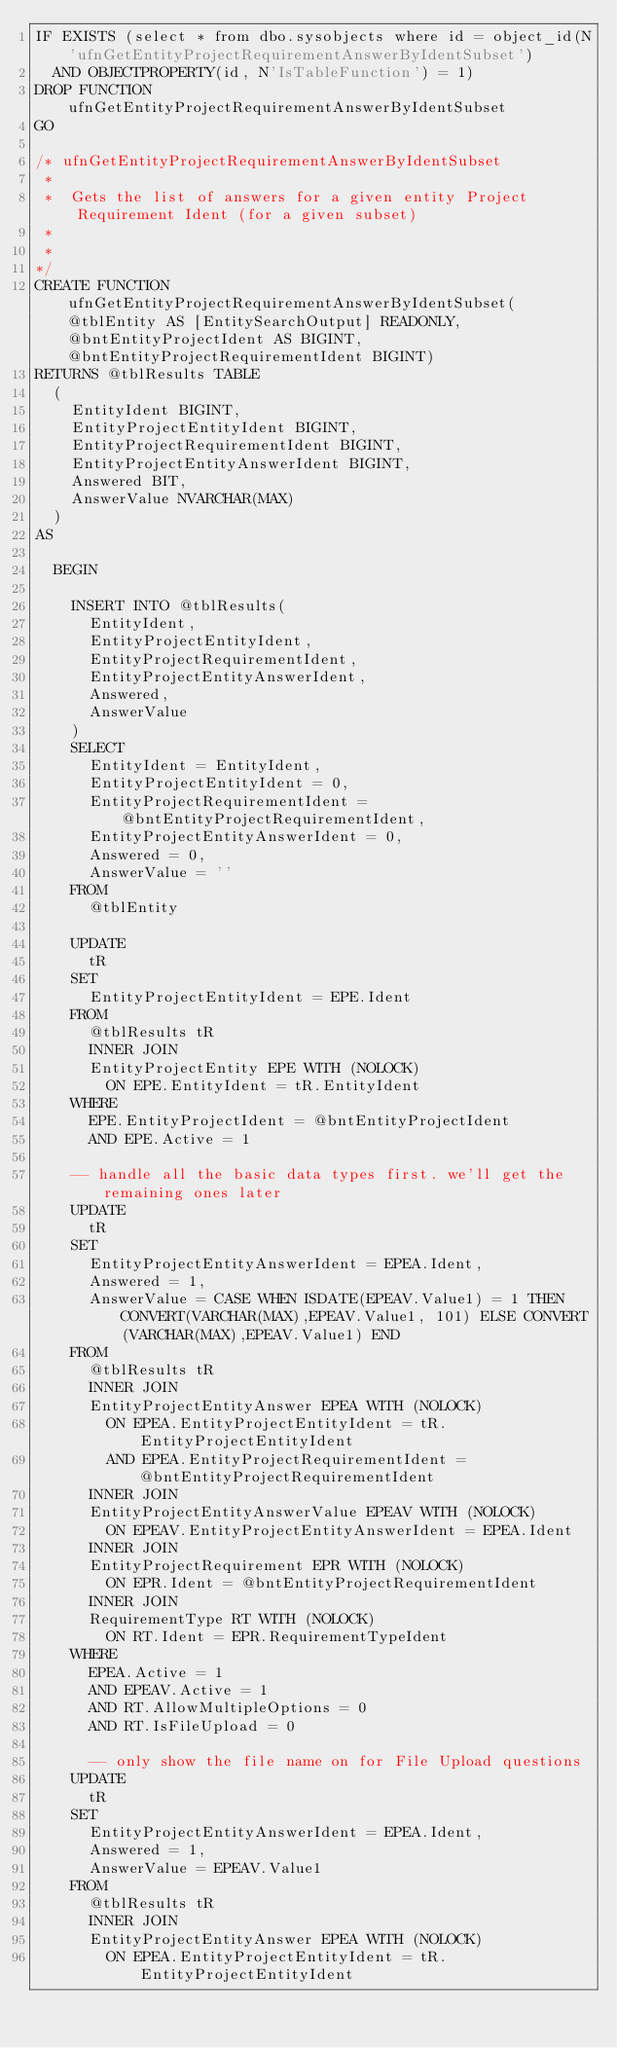Convert code to text. <code><loc_0><loc_0><loc_500><loc_500><_SQL_>IF EXISTS (select * from dbo.sysobjects where id = object_id(N'ufnGetEntityProjectRequirementAnswerByIdentSubset') 
	AND OBJECTPROPERTY(id, N'IsTableFunction') = 1)
DROP FUNCTION ufnGetEntityProjectRequirementAnswerByIdentSubset
GO

/* ufnGetEntityProjectRequirementAnswerByIdentSubset
 *
 *  Gets the list of answers for a given entity Project Requirement Ident (for a given subset)
 *
 *
*/
CREATE FUNCTION ufnGetEntityProjectRequirementAnswerByIdentSubset(@tblEntity AS [EntitySearchOutput] READONLY, @bntEntityProjectIdent AS BIGINT, @bntEntityProjectRequirementIdent BIGINT)
RETURNS @tblResults TABLE
	(
		EntityIdent BIGINT,
		EntityProjectEntityIdent BIGINT,
		EntityProjectRequirementIdent BIGINT,
		EntityProjectEntityAnswerIdent BIGINT,
		Answered BIT,
		AnswerValue NVARCHAR(MAX)
	)
AS

	BEGIN

		INSERT INTO @tblResults(
			EntityIdent,
			EntityProjectEntityIdent,
			EntityProjectRequirementIdent,
			EntityProjectEntityAnswerIdent,
			Answered,
			AnswerValue
		)
		SELECT
			EntityIdent = EntityIdent,
			EntityProjectEntityIdent = 0,
			EntityProjectRequirementIdent = @bntEntityProjectRequirementIdent,
			EntityProjectEntityAnswerIdent = 0,
			Answered = 0,
			AnswerValue = ''
		FROM
			@tblEntity

		UPDATE
			tR
		SET
			EntityProjectEntityIdent = EPE.Ident
		FROM
			@tblResults tR
			INNER JOIN
			EntityProjectEntity EPE WITH (NOLOCK)
				ON EPE.EntityIdent = tR.EntityIdent
		WHERE
			EPE.EntityProjectIdent = @bntEntityProjectIdent
			AND EPE.Active = 1

		-- handle all the basic data types first. we'll get the remaining ones later
		UPDATE
			tR
		SET
			EntityProjectEntityAnswerIdent = EPEA.Ident,
			Answered = 1,
			AnswerValue = CASE WHEN ISDATE(EPEAV.Value1) = 1 THEN CONVERT(VARCHAR(MAX),EPEAV.Value1, 101) ELSE CONVERT(VARCHAR(MAX),EPEAV.Value1) END
		FROM
			@tblResults tR
			INNER JOIN
			EntityProjectEntityAnswer EPEA WITH (NOLOCK)
				ON EPEA.EntityProjectEntityIdent = tR.EntityProjectEntityIdent
				AND EPEA.EntityProjectRequirementIdent = @bntEntityProjectRequirementIdent
			INNER JOIN
			EntityProjectEntityAnswerValue EPEAV WITH (NOLOCK)
				ON EPEAV.EntityProjectEntityAnswerIdent = EPEA.Ident
			INNER JOIN
			EntityProjectRequirement EPR WITH (NOLOCK)
				ON EPR.Ident = @bntEntityProjectRequirementIdent
			INNER JOIN
			RequirementType RT WITH (NOLOCK)
				ON RT.Ident = EPR.RequirementTypeIdent
		WHERE
			EPEA.Active = 1
			AND EPEAV.Active = 1
			AND RT.AllowMultipleOptions = 0
			AND RT.IsFileUpload = 0

			-- only show the file name on for File Upload questions
		UPDATE
			tR
		SET
			EntityProjectEntityAnswerIdent = EPEA.Ident,
			Answered = 1,
			AnswerValue = EPEAV.Value1
		FROM
			@tblResults tR
			INNER JOIN
			EntityProjectEntityAnswer EPEA WITH (NOLOCK)
				ON EPEA.EntityProjectEntityIdent = tR.EntityProjectEntityIdent</code> 